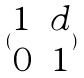Convert formula to latex. <formula><loc_0><loc_0><loc_500><loc_500>( \begin{matrix} 1 & d \\ 0 & 1 \end{matrix} )</formula> 